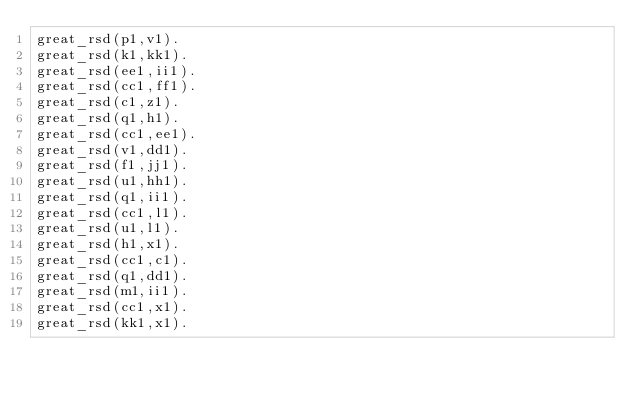<code> <loc_0><loc_0><loc_500><loc_500><_FORTRAN_>great_rsd(p1,v1).
great_rsd(k1,kk1).
great_rsd(ee1,ii1).
great_rsd(cc1,ff1).
great_rsd(c1,z1).
great_rsd(q1,h1).
great_rsd(cc1,ee1).
great_rsd(v1,dd1).
great_rsd(f1,jj1).
great_rsd(u1,hh1).
great_rsd(q1,ii1).
great_rsd(cc1,l1).
great_rsd(u1,l1).
great_rsd(h1,x1).
great_rsd(cc1,c1).
great_rsd(q1,dd1).
great_rsd(m1,ii1).
great_rsd(cc1,x1).
great_rsd(kk1,x1).
</code> 